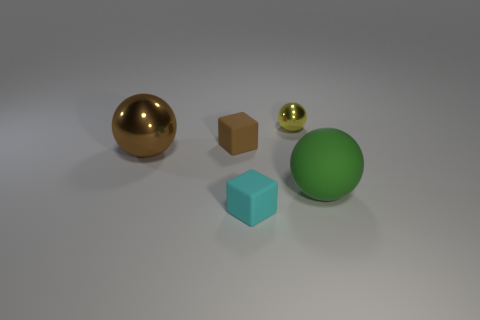Is there any object that stands out in the image due to its size or color? The large green sphere stands out due to its size, being the largest object in the image. Additionally, the gold sphere is quite noticeable because of its reflective glossy surface and distinct golden color. 
Could you guess the texture of these objects just by looking at them? While a visual assessment can't provide certainty on texture, the gold sphere looks smooth and likely has a glossy texture; the brown cube seems to have a matte, slightly rough texture; the green spheres seem smooth with a slight glossiness, and the small cyan block appears to have a smooth, rubber-like texture. 